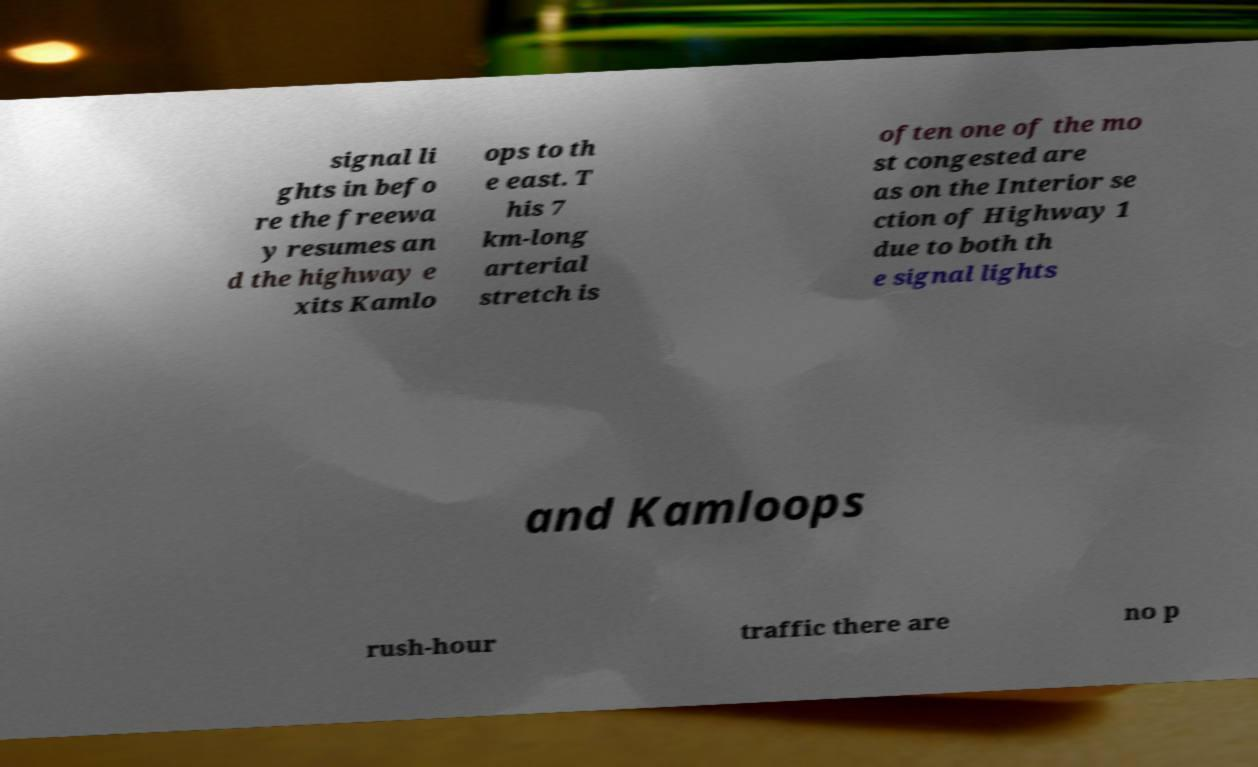Please read and relay the text visible in this image. What does it say? signal li ghts in befo re the freewa y resumes an d the highway e xits Kamlo ops to th e east. T his 7 km-long arterial stretch is often one of the mo st congested are as on the Interior se ction of Highway 1 due to both th e signal lights and Kamloops rush-hour traffic there are no p 